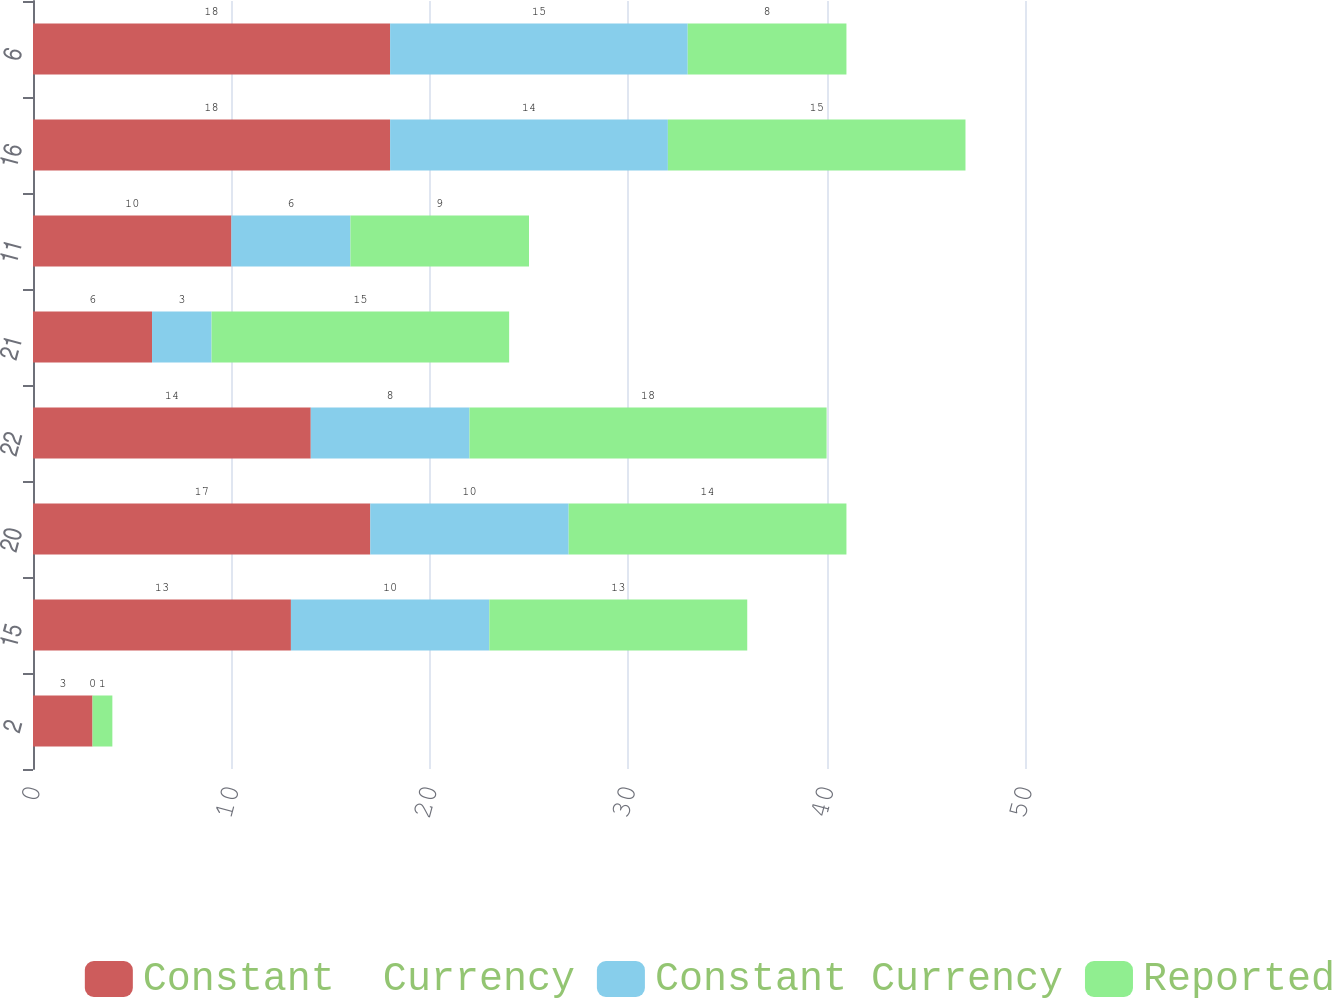Convert chart. <chart><loc_0><loc_0><loc_500><loc_500><stacked_bar_chart><ecel><fcel>2<fcel>15<fcel>20<fcel>22<fcel>21<fcel>11<fcel>16<fcel>6<nl><fcel>Constant  Currency<fcel>3<fcel>13<fcel>17<fcel>14<fcel>6<fcel>10<fcel>18<fcel>18<nl><fcel>Constant Currency<fcel>0<fcel>10<fcel>10<fcel>8<fcel>3<fcel>6<fcel>14<fcel>15<nl><fcel>Reported<fcel>1<fcel>13<fcel>14<fcel>18<fcel>15<fcel>9<fcel>15<fcel>8<nl></chart> 